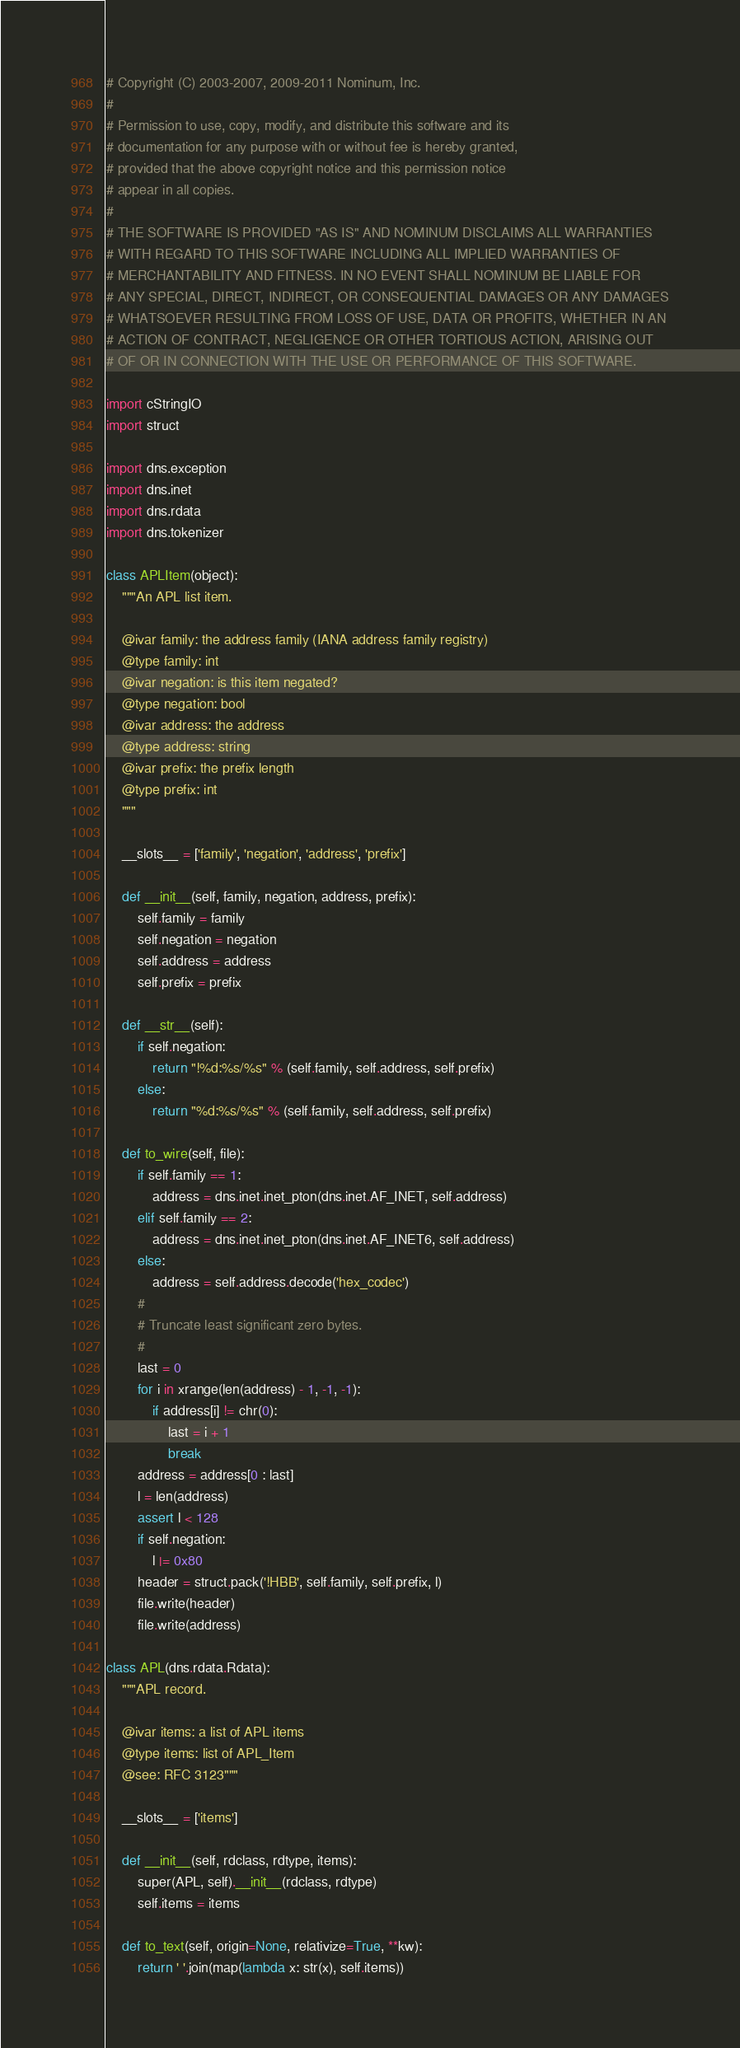<code> <loc_0><loc_0><loc_500><loc_500><_Python_># Copyright (C) 2003-2007, 2009-2011 Nominum, Inc.
#
# Permission to use, copy, modify, and distribute this software and its
# documentation for any purpose with or without fee is hereby granted,
# provided that the above copyright notice and this permission notice
# appear in all copies.
#
# THE SOFTWARE IS PROVIDED "AS IS" AND NOMINUM DISCLAIMS ALL WARRANTIES
# WITH REGARD TO THIS SOFTWARE INCLUDING ALL IMPLIED WARRANTIES OF
# MERCHANTABILITY AND FITNESS. IN NO EVENT SHALL NOMINUM BE LIABLE FOR
# ANY SPECIAL, DIRECT, INDIRECT, OR CONSEQUENTIAL DAMAGES OR ANY DAMAGES
# WHATSOEVER RESULTING FROM LOSS OF USE, DATA OR PROFITS, WHETHER IN AN
# ACTION OF CONTRACT, NEGLIGENCE OR OTHER TORTIOUS ACTION, ARISING OUT
# OF OR IN CONNECTION WITH THE USE OR PERFORMANCE OF THIS SOFTWARE.

import cStringIO
import struct

import dns.exception
import dns.inet
import dns.rdata
import dns.tokenizer

class APLItem(object):
    """An APL list item.

    @ivar family: the address family (IANA address family registry)
    @type family: int
    @ivar negation: is this item negated?
    @type negation: bool
    @ivar address: the address
    @type address: string
    @ivar prefix: the prefix length
    @type prefix: int
    """

    __slots__ = ['family', 'negation', 'address', 'prefix']

    def __init__(self, family, negation, address, prefix):
        self.family = family
        self.negation = negation
        self.address = address
        self.prefix = prefix

    def __str__(self):
        if self.negation:
            return "!%d:%s/%s" % (self.family, self.address, self.prefix)
        else:
            return "%d:%s/%s" % (self.family, self.address, self.prefix)

    def to_wire(self, file):
        if self.family == 1:
            address = dns.inet.inet_pton(dns.inet.AF_INET, self.address)
        elif self.family == 2:
            address = dns.inet.inet_pton(dns.inet.AF_INET6, self.address)
        else:
            address = self.address.decode('hex_codec')
        #
        # Truncate least significant zero bytes.
        #
        last = 0
        for i in xrange(len(address) - 1, -1, -1):
            if address[i] != chr(0):
                last = i + 1
                break
        address = address[0 : last]
        l = len(address)
        assert l < 128
        if self.negation:
            l |= 0x80
        header = struct.pack('!HBB', self.family, self.prefix, l)
        file.write(header)
        file.write(address)

class APL(dns.rdata.Rdata):
    """APL record.

    @ivar items: a list of APL items
    @type items: list of APL_Item
    @see: RFC 3123"""

    __slots__ = ['items']

    def __init__(self, rdclass, rdtype, items):
        super(APL, self).__init__(rdclass, rdtype)
        self.items = items

    def to_text(self, origin=None, relativize=True, **kw):
        return ' '.join(map(lambda x: str(x), self.items))
</code> 